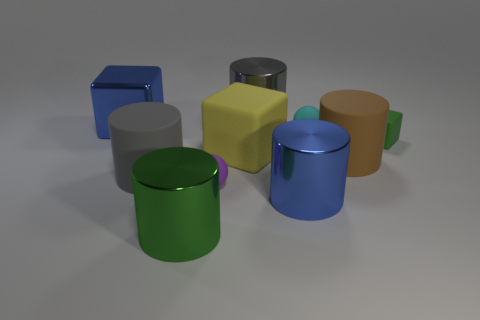Is the shape of the purple thing the same as the big green thing?
Offer a very short reply. No. Is the size of the blue block the same as the rubber cylinder on the right side of the tiny purple matte object?
Your answer should be compact. Yes. How big is the blue thing that is to the left of the blue shiny thing that is in front of the small sphere that is left of the big yellow cube?
Keep it short and to the point. Large. Is there a rubber cylinder?
Your answer should be compact. Yes. What material is the large cylinder that is the same color as the shiny block?
Your response must be concise. Metal. What number of large metallic things have the same color as the shiny block?
Ensure brevity in your answer.  1. What number of objects are matte spheres in front of the big gray matte thing or cylinders behind the blue metal cube?
Your answer should be very brief. 2. There is a rubber block that is in front of the small green rubber cube; how many brown cylinders are in front of it?
Provide a succinct answer. 1. There is another large block that is the same material as the green block; what is its color?
Your answer should be very brief. Yellow. Is there another yellow matte block that has the same size as the yellow block?
Offer a very short reply. No. 